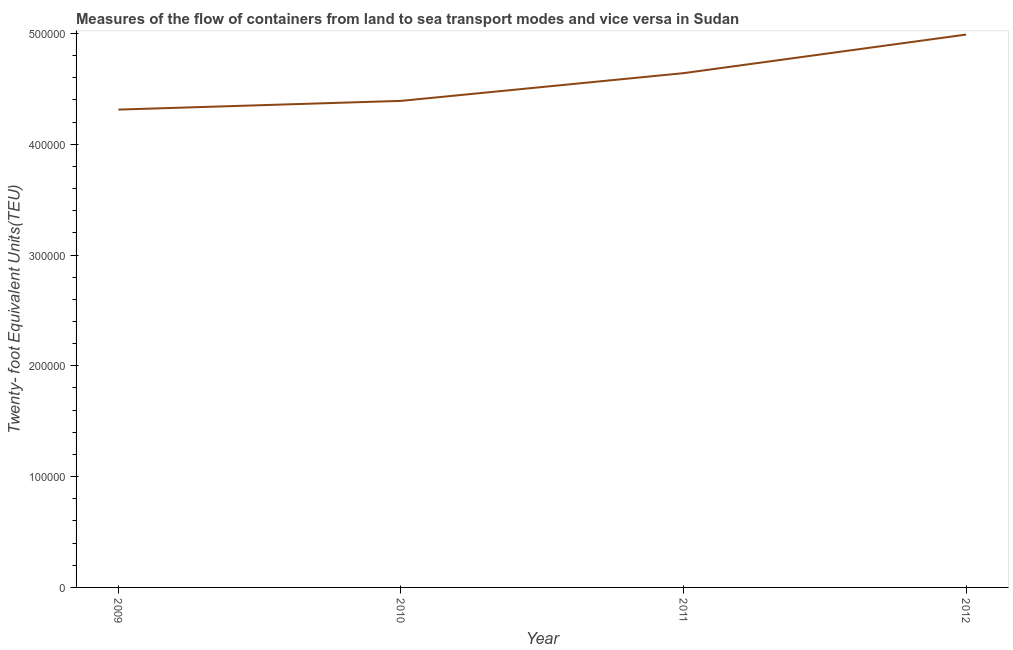What is the container port traffic in 2011?
Ensure brevity in your answer.  4.64e+05. Across all years, what is the maximum container port traffic?
Provide a succinct answer. 4.99e+05. Across all years, what is the minimum container port traffic?
Make the answer very short. 4.31e+05. In which year was the container port traffic minimum?
Your answer should be compact. 2009. What is the sum of the container port traffic?
Ensure brevity in your answer.  1.83e+06. What is the difference between the container port traffic in 2010 and 2012?
Your answer should be compact. -5.98e+04. What is the average container port traffic per year?
Make the answer very short. 4.58e+05. What is the median container port traffic?
Provide a succinct answer. 4.52e+05. What is the ratio of the container port traffic in 2011 to that in 2012?
Provide a succinct answer. 0.93. Is the container port traffic in 2010 less than that in 2011?
Give a very brief answer. Yes. Is the difference between the container port traffic in 2009 and 2011 greater than the difference between any two years?
Offer a terse response. No. What is the difference between the highest and the second highest container port traffic?
Offer a very short reply. 3.48e+04. Is the sum of the container port traffic in 2011 and 2012 greater than the maximum container port traffic across all years?
Keep it short and to the point. Yes. What is the difference between the highest and the lowest container port traffic?
Make the answer very short. 6.77e+04. In how many years, is the container port traffic greater than the average container port traffic taken over all years?
Give a very brief answer. 2. Are the values on the major ticks of Y-axis written in scientific E-notation?
Your answer should be compact. No. Does the graph contain any zero values?
Offer a very short reply. No. What is the title of the graph?
Ensure brevity in your answer.  Measures of the flow of containers from land to sea transport modes and vice versa in Sudan. What is the label or title of the Y-axis?
Ensure brevity in your answer.  Twenty- foot Equivalent Units(TEU). What is the Twenty- foot Equivalent Units(TEU) in 2009?
Ensure brevity in your answer.  4.31e+05. What is the Twenty- foot Equivalent Units(TEU) of 2010?
Offer a very short reply. 4.39e+05. What is the Twenty- foot Equivalent Units(TEU) of 2011?
Keep it short and to the point. 4.64e+05. What is the Twenty- foot Equivalent Units(TEU) in 2012?
Keep it short and to the point. 4.99e+05. What is the difference between the Twenty- foot Equivalent Units(TEU) in 2009 and 2010?
Your answer should be compact. -7868. What is the difference between the Twenty- foot Equivalent Units(TEU) in 2009 and 2011?
Your answer should be very brief. -3.29e+04. What is the difference between the Twenty- foot Equivalent Units(TEU) in 2009 and 2012?
Your answer should be compact. -6.77e+04. What is the difference between the Twenty- foot Equivalent Units(TEU) in 2010 and 2011?
Provide a short and direct response. -2.50e+04. What is the difference between the Twenty- foot Equivalent Units(TEU) in 2010 and 2012?
Keep it short and to the point. -5.98e+04. What is the difference between the Twenty- foot Equivalent Units(TEU) in 2011 and 2012?
Offer a terse response. -3.48e+04. What is the ratio of the Twenty- foot Equivalent Units(TEU) in 2009 to that in 2010?
Make the answer very short. 0.98. What is the ratio of the Twenty- foot Equivalent Units(TEU) in 2009 to that in 2011?
Your answer should be compact. 0.93. What is the ratio of the Twenty- foot Equivalent Units(TEU) in 2009 to that in 2012?
Give a very brief answer. 0.86. What is the ratio of the Twenty- foot Equivalent Units(TEU) in 2010 to that in 2011?
Your answer should be very brief. 0.95. What is the ratio of the Twenty- foot Equivalent Units(TEU) in 2011 to that in 2012?
Ensure brevity in your answer.  0.93. 